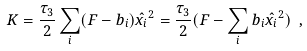Convert formula to latex. <formula><loc_0><loc_0><loc_500><loc_500>K = { \frac { \tau _ { 3 } } { 2 } } \sum _ { i } ( F - b _ { i } ) \hat { x _ { i } } ^ { 2 } = { \frac { \tau _ { 3 } } { 2 } } ( F - \sum _ { i } b _ { i } \hat { x _ { i } } ^ { 2 } ) \ ,</formula> 